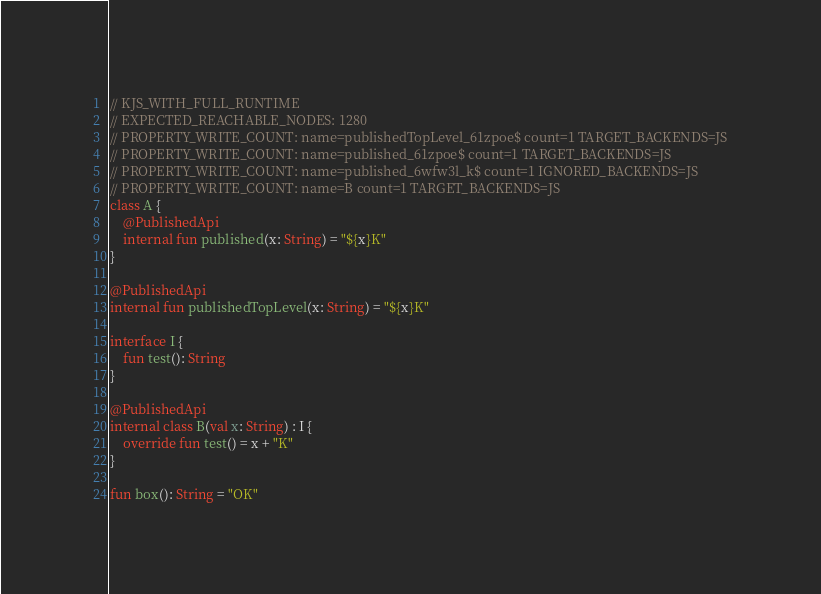<code> <loc_0><loc_0><loc_500><loc_500><_Kotlin_>// KJS_WITH_FULL_RUNTIME
// EXPECTED_REACHABLE_NODES: 1280
// PROPERTY_WRITE_COUNT: name=publishedTopLevel_61zpoe$ count=1 TARGET_BACKENDS=JS
// PROPERTY_WRITE_COUNT: name=published_61zpoe$ count=1 TARGET_BACKENDS=JS
// PROPERTY_WRITE_COUNT: name=published_6wfw3l_k$ count=1 IGNORED_BACKENDS=JS
// PROPERTY_WRITE_COUNT: name=B count=1 TARGET_BACKENDS=JS
class A {
    @PublishedApi
    internal fun published(x: String) = "${x}K"
}

@PublishedApi
internal fun publishedTopLevel(x: String) = "${x}K"

interface I {
    fun test(): String
}

@PublishedApi
internal class B(val x: String) : I {
    override fun test() = x + "K"
}

fun box(): String = "OK"
</code> 